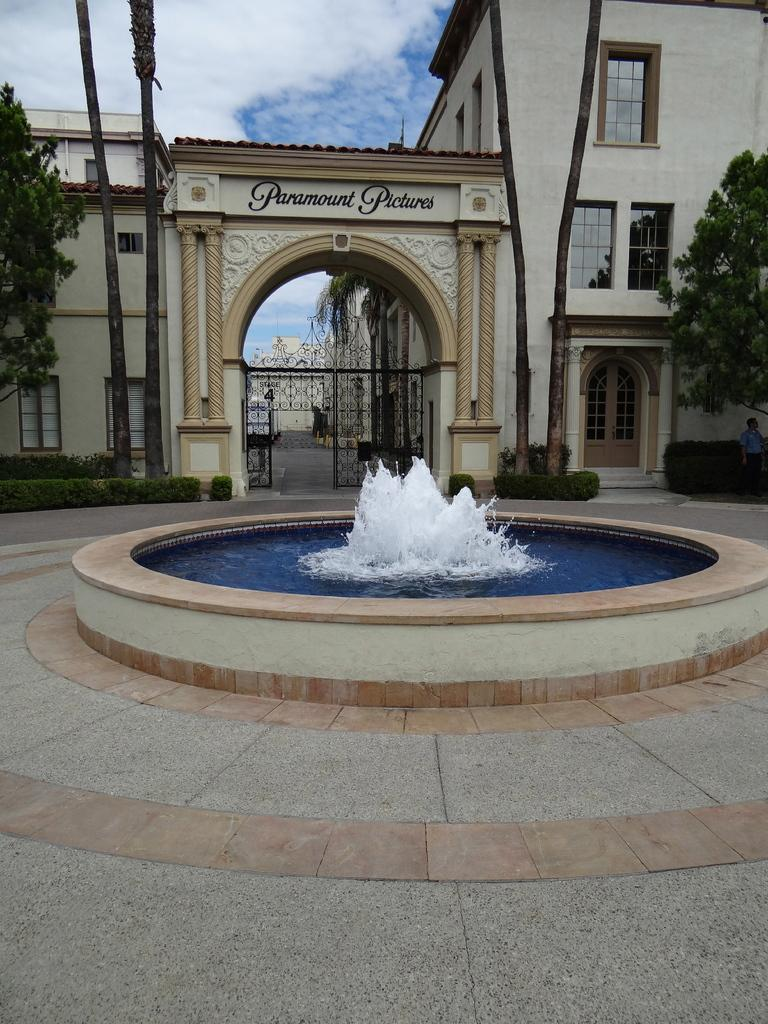What type of structure can be seen in the image? There is a building in the image. What is the entrance to the building like? There is a gate in the image. What type of vegetation is present in the image? There are trees and shrubs in the image. What type of water feature is present in the image? There is a water fountain in the image. Can you describe the person on the right side of the image? There is a person on the right side of the image. What type of path is present in the image? There is a path in the image. What is visible in the sky in the image? The sky is visible in the image, and there are clouds in the sky. What type of shirt is the dog wearing in the image? There is no dog present in the image, and therefore no shirt or any clothing item can be observed. What type of pan is being used to cook the food in the image? There is no pan or any cooking activity present in the image. 